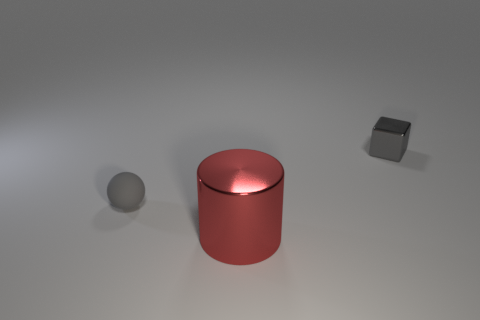Add 2 big cyan metallic things. How many objects exist? 5 Subtract all cubes. How many objects are left? 2 Add 3 small gray shiny things. How many small gray shiny things exist? 4 Subtract 1 gray cubes. How many objects are left? 2 Subtract all large green metal spheres. Subtract all large red metallic cylinders. How many objects are left? 2 Add 3 gray matte balls. How many gray matte balls are left? 4 